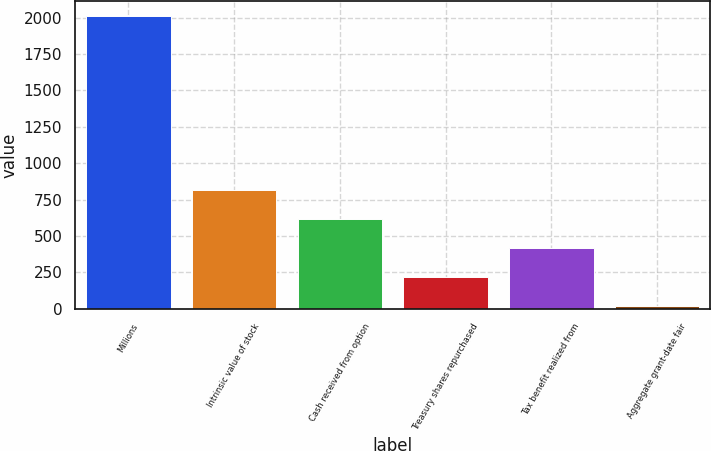Convert chart to OTSL. <chart><loc_0><loc_0><loc_500><loc_500><bar_chart><fcel>Millions<fcel>Intrinsic value of stock<fcel>Cash received from option<fcel>Treasury shares repurchased<fcel>Tax benefit realized from<fcel>Aggregate grant-date fair<nl><fcel>2013<fcel>814.8<fcel>615.1<fcel>215.7<fcel>415.4<fcel>16<nl></chart> 